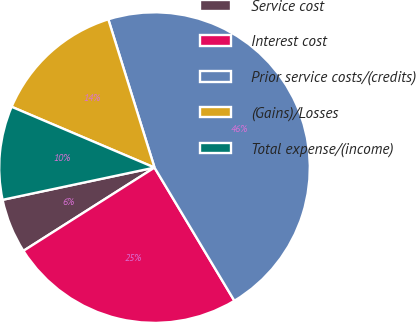<chart> <loc_0><loc_0><loc_500><loc_500><pie_chart><fcel>Service cost<fcel>Interest cost<fcel>Prior service costs/(credits)<fcel>(Gains)/Losses<fcel>Total expense/(income)<nl><fcel>5.68%<fcel>24.59%<fcel>46.21%<fcel>13.79%<fcel>9.73%<nl></chart> 